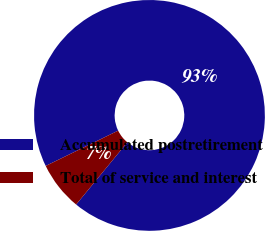<chart> <loc_0><loc_0><loc_500><loc_500><pie_chart><fcel>Accumulated postretirement<fcel>Total of service and interest<nl><fcel>93.17%<fcel>6.83%<nl></chart> 